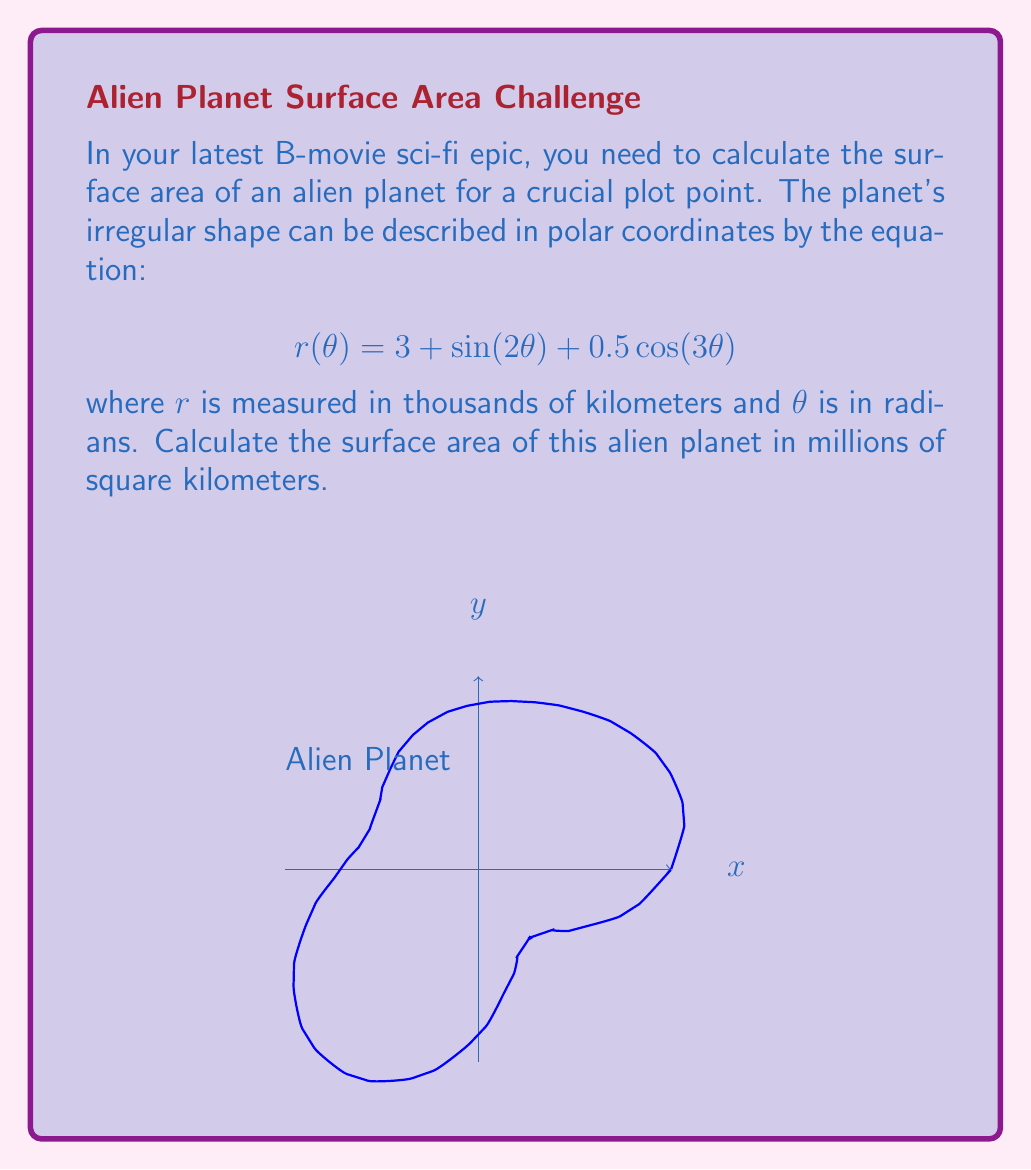What is the answer to this math problem? To find the surface area of the planet, we need to use the formula for the area in polar coordinates:

$$A = \frac{1}{2}\int_0^{2\pi} [r(\theta)]^2 d\theta$$

Let's break this down step-by-step:

1) First, we square the given function $r(\theta)$:
   $$[r(\theta)]^2 = (3 + \sin(2\theta) + 0.5\cos(3\theta))^2$$

2) Expand this:
   $$[r(\theta)]^2 = 9 + 6\sin(2\theta) + 3\cos(3\theta) + \sin^2(2\theta) + \sin(2\theta)\cos(3\theta) + 0.25\cos^2(3\theta)$$

3) Now, we need to integrate this from 0 to $2\pi$:
   $$A = \frac{1}{2}\int_0^{2\pi} (9 + 6\sin(2\theta) + 3\cos(3\theta) + \sin^2(2\theta) + \sin(2\theta)\cos(3\theta) + 0.25\cos^2(3\theta)) d\theta$$

4) Integrate each term:
   - $\int_0^{2\pi} 9 d\theta = 18\pi$
   - $\int_0^{2\pi} 6\sin(2\theta) d\theta = 0$
   - $\int_0^{2\pi} 3\cos(3\theta) d\theta = 0$
   - $\int_0^{2\pi} \sin^2(2\theta) d\theta = \pi$
   - $\int_0^{2\pi} \sin(2\theta)\cos(3\theta) d\theta = 0$
   - $\int_0^{2\pi} 0.25\cos^2(3\theta) d\theta = 0.25\pi$

5) Sum up all these integrals:
   $$A = \frac{1}{2}(18\pi + \pi + 0.25\pi) = 9.625\pi$$

6) Remember that $r$ was measured in thousands of kilometers, so our result is in millions of square kilometers.

Thus, the surface area of the alien planet is $9.625\pi$ million square kilometers.
Answer: $30.24$ million km² 